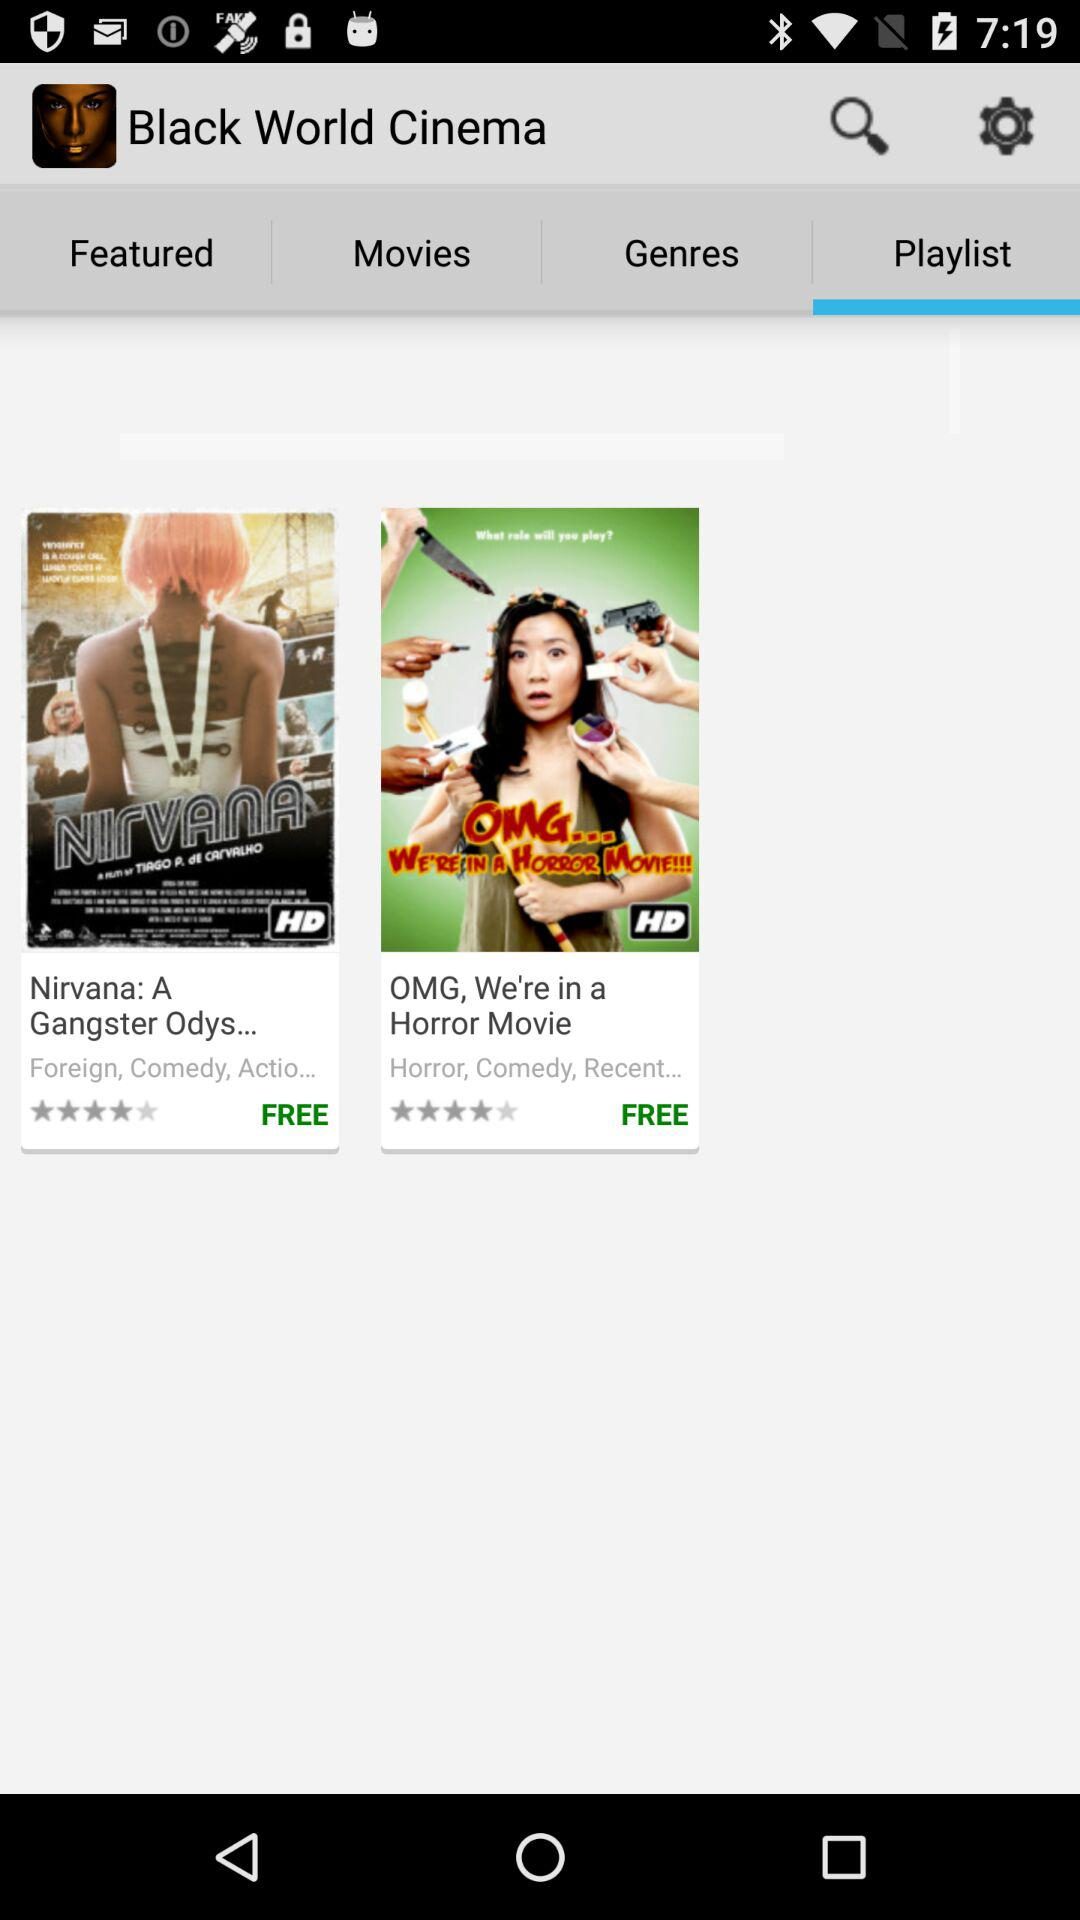Which tab is selected? The selected tab is "Playlist". 